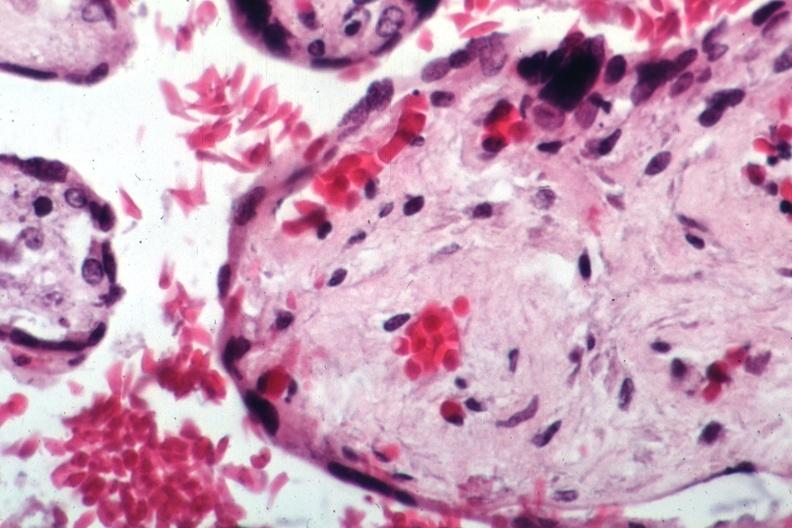does omentum show sickled maternal cells readily evident?
Answer the question using a single word or phrase. No 